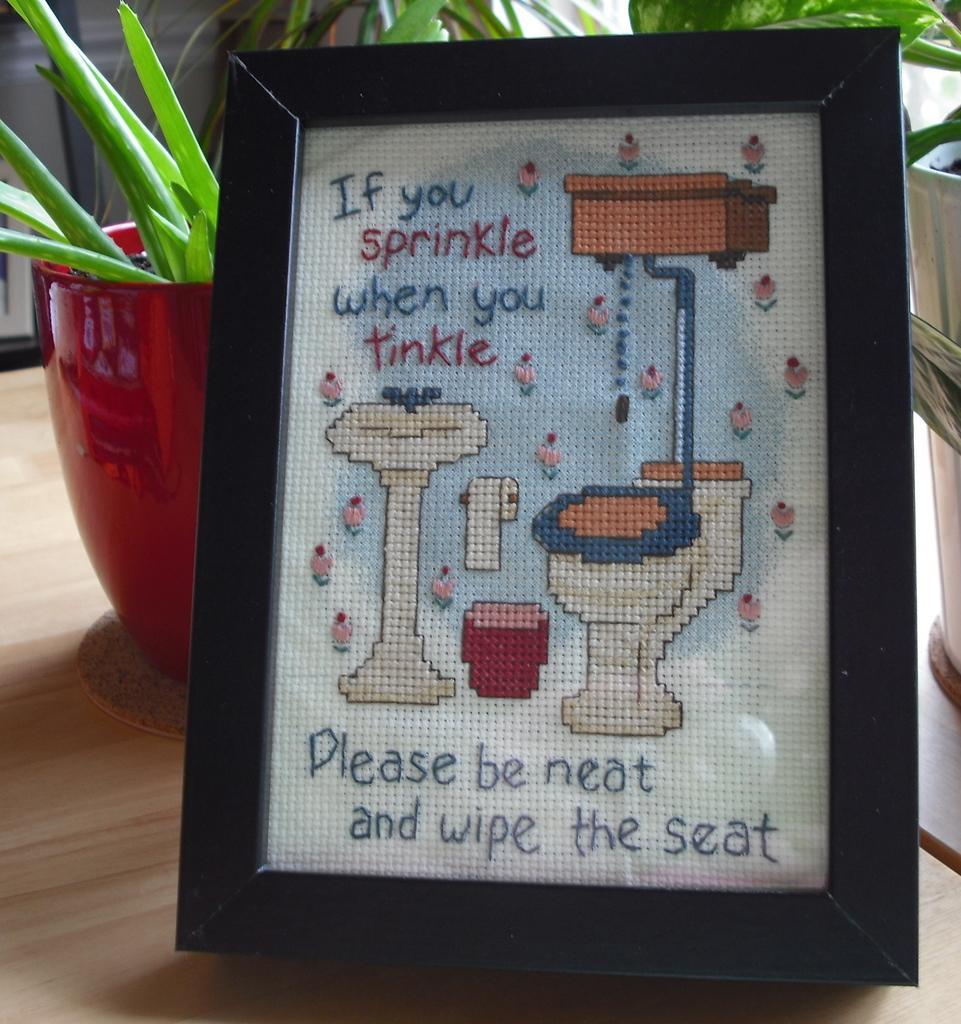Can you describe this image briefly? In this image I can see flower pots, a photo frame on which something written on it. These objects are on a wooden surface. 